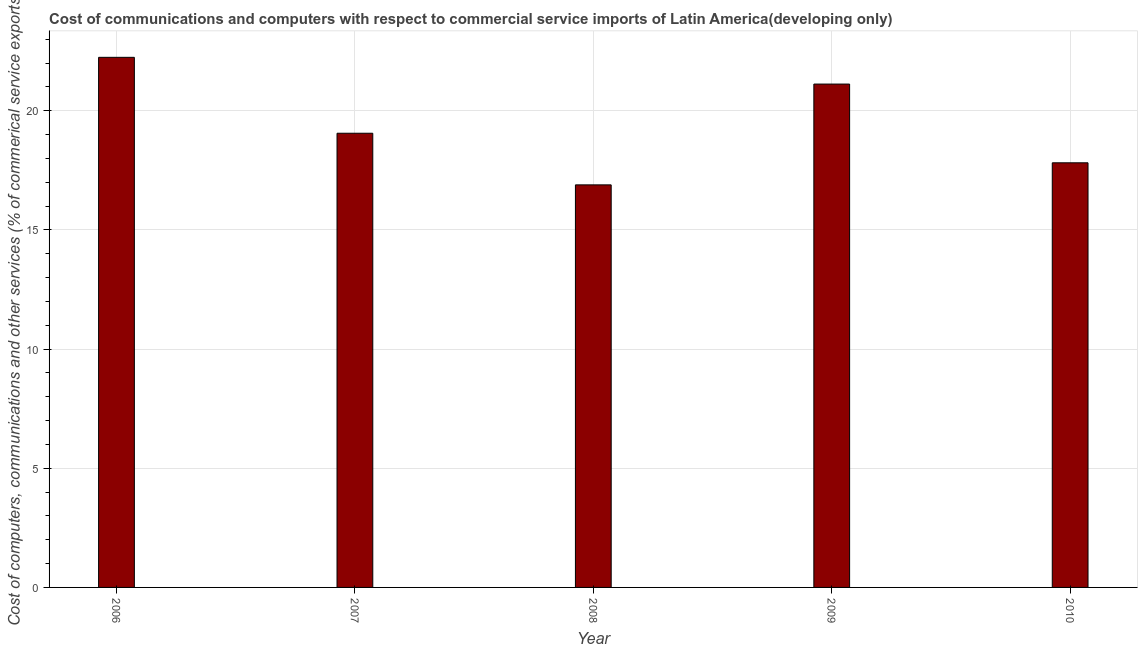Does the graph contain any zero values?
Provide a succinct answer. No. Does the graph contain grids?
Your answer should be compact. Yes. What is the title of the graph?
Your response must be concise. Cost of communications and computers with respect to commercial service imports of Latin America(developing only). What is the label or title of the X-axis?
Ensure brevity in your answer.  Year. What is the label or title of the Y-axis?
Keep it short and to the point. Cost of computers, communications and other services (% of commerical service exports). What is the  computer and other services in 2006?
Ensure brevity in your answer.  22.24. Across all years, what is the maximum cost of communications?
Your response must be concise. 22.24. Across all years, what is the minimum cost of communications?
Offer a terse response. 16.89. In which year was the cost of communications maximum?
Ensure brevity in your answer.  2006. What is the sum of the  computer and other services?
Offer a terse response. 97.11. What is the difference between the cost of communications in 2007 and 2010?
Make the answer very short. 1.24. What is the average  computer and other services per year?
Provide a short and direct response. 19.42. What is the median  computer and other services?
Offer a terse response. 19.05. In how many years, is the  computer and other services greater than 15 %?
Offer a terse response. 5. Do a majority of the years between 2007 and 2010 (inclusive) have cost of communications greater than 3 %?
Make the answer very short. Yes. What is the ratio of the cost of communications in 2007 to that in 2008?
Your answer should be very brief. 1.13. What is the difference between the highest and the second highest  computer and other services?
Make the answer very short. 1.12. What is the difference between the highest and the lowest cost of communications?
Ensure brevity in your answer.  5.35. In how many years, is the  computer and other services greater than the average  computer and other services taken over all years?
Keep it short and to the point. 2. Are all the bars in the graph horizontal?
Ensure brevity in your answer.  No. How many years are there in the graph?
Your response must be concise. 5. What is the difference between two consecutive major ticks on the Y-axis?
Ensure brevity in your answer.  5. Are the values on the major ticks of Y-axis written in scientific E-notation?
Provide a short and direct response. No. What is the Cost of computers, communications and other services (% of commerical service exports) of 2006?
Ensure brevity in your answer.  22.24. What is the Cost of computers, communications and other services (% of commerical service exports) of 2007?
Provide a succinct answer. 19.05. What is the Cost of computers, communications and other services (% of commerical service exports) of 2008?
Give a very brief answer. 16.89. What is the Cost of computers, communications and other services (% of commerical service exports) in 2009?
Give a very brief answer. 21.12. What is the Cost of computers, communications and other services (% of commerical service exports) in 2010?
Make the answer very short. 17.81. What is the difference between the Cost of computers, communications and other services (% of commerical service exports) in 2006 and 2007?
Ensure brevity in your answer.  3.18. What is the difference between the Cost of computers, communications and other services (% of commerical service exports) in 2006 and 2008?
Your response must be concise. 5.35. What is the difference between the Cost of computers, communications and other services (% of commerical service exports) in 2006 and 2009?
Your answer should be very brief. 1.12. What is the difference between the Cost of computers, communications and other services (% of commerical service exports) in 2006 and 2010?
Your answer should be very brief. 4.42. What is the difference between the Cost of computers, communications and other services (% of commerical service exports) in 2007 and 2008?
Ensure brevity in your answer.  2.17. What is the difference between the Cost of computers, communications and other services (% of commerical service exports) in 2007 and 2009?
Your response must be concise. -2.06. What is the difference between the Cost of computers, communications and other services (% of commerical service exports) in 2007 and 2010?
Your answer should be compact. 1.24. What is the difference between the Cost of computers, communications and other services (% of commerical service exports) in 2008 and 2009?
Provide a succinct answer. -4.23. What is the difference between the Cost of computers, communications and other services (% of commerical service exports) in 2008 and 2010?
Provide a succinct answer. -0.93. What is the difference between the Cost of computers, communications and other services (% of commerical service exports) in 2009 and 2010?
Offer a terse response. 3.3. What is the ratio of the Cost of computers, communications and other services (% of commerical service exports) in 2006 to that in 2007?
Ensure brevity in your answer.  1.17. What is the ratio of the Cost of computers, communications and other services (% of commerical service exports) in 2006 to that in 2008?
Give a very brief answer. 1.32. What is the ratio of the Cost of computers, communications and other services (% of commerical service exports) in 2006 to that in 2009?
Provide a succinct answer. 1.05. What is the ratio of the Cost of computers, communications and other services (% of commerical service exports) in 2006 to that in 2010?
Offer a terse response. 1.25. What is the ratio of the Cost of computers, communications and other services (% of commerical service exports) in 2007 to that in 2008?
Provide a short and direct response. 1.13. What is the ratio of the Cost of computers, communications and other services (% of commerical service exports) in 2007 to that in 2009?
Your answer should be compact. 0.9. What is the ratio of the Cost of computers, communications and other services (% of commerical service exports) in 2007 to that in 2010?
Your response must be concise. 1.07. What is the ratio of the Cost of computers, communications and other services (% of commerical service exports) in 2008 to that in 2009?
Provide a short and direct response. 0.8. What is the ratio of the Cost of computers, communications and other services (% of commerical service exports) in 2008 to that in 2010?
Make the answer very short. 0.95. What is the ratio of the Cost of computers, communications and other services (% of commerical service exports) in 2009 to that in 2010?
Your answer should be very brief. 1.19. 